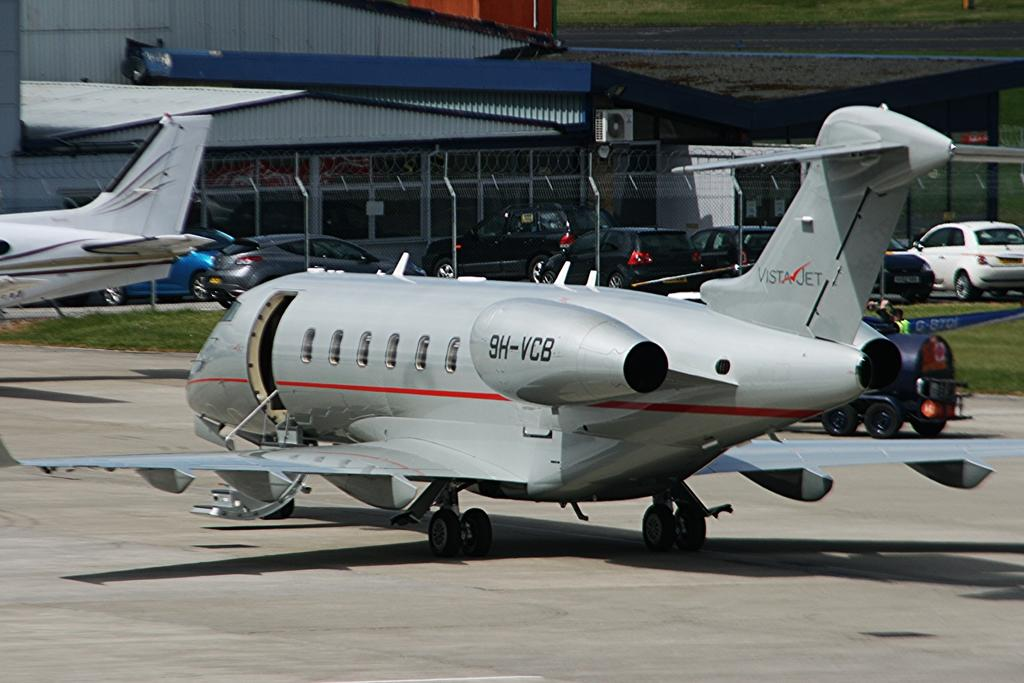How many air crafts are in the image? There are two air crafts in the image. What else can be seen in the image besides air crafts? There are vehicles, a person on a vehicle, a building, an air conditioner, and grass visible in the image. Can you describe the person in the image? The person is on a vehicle. What type of structure is present in the image? There is a building in the image. What is the purpose of the air conditioner in the image? The purpose of the air conditioner is to provide cooling. What type of sail can be seen on the person's boat in the image? There is no boat or sail present in the image. What is the person's interest in the image? There is no information about the person's interests in the image. 